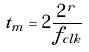Convert formula to latex. <formula><loc_0><loc_0><loc_500><loc_500>t _ { m } = 2 \frac { 2 ^ { r } } { f _ { c l k } }</formula> 